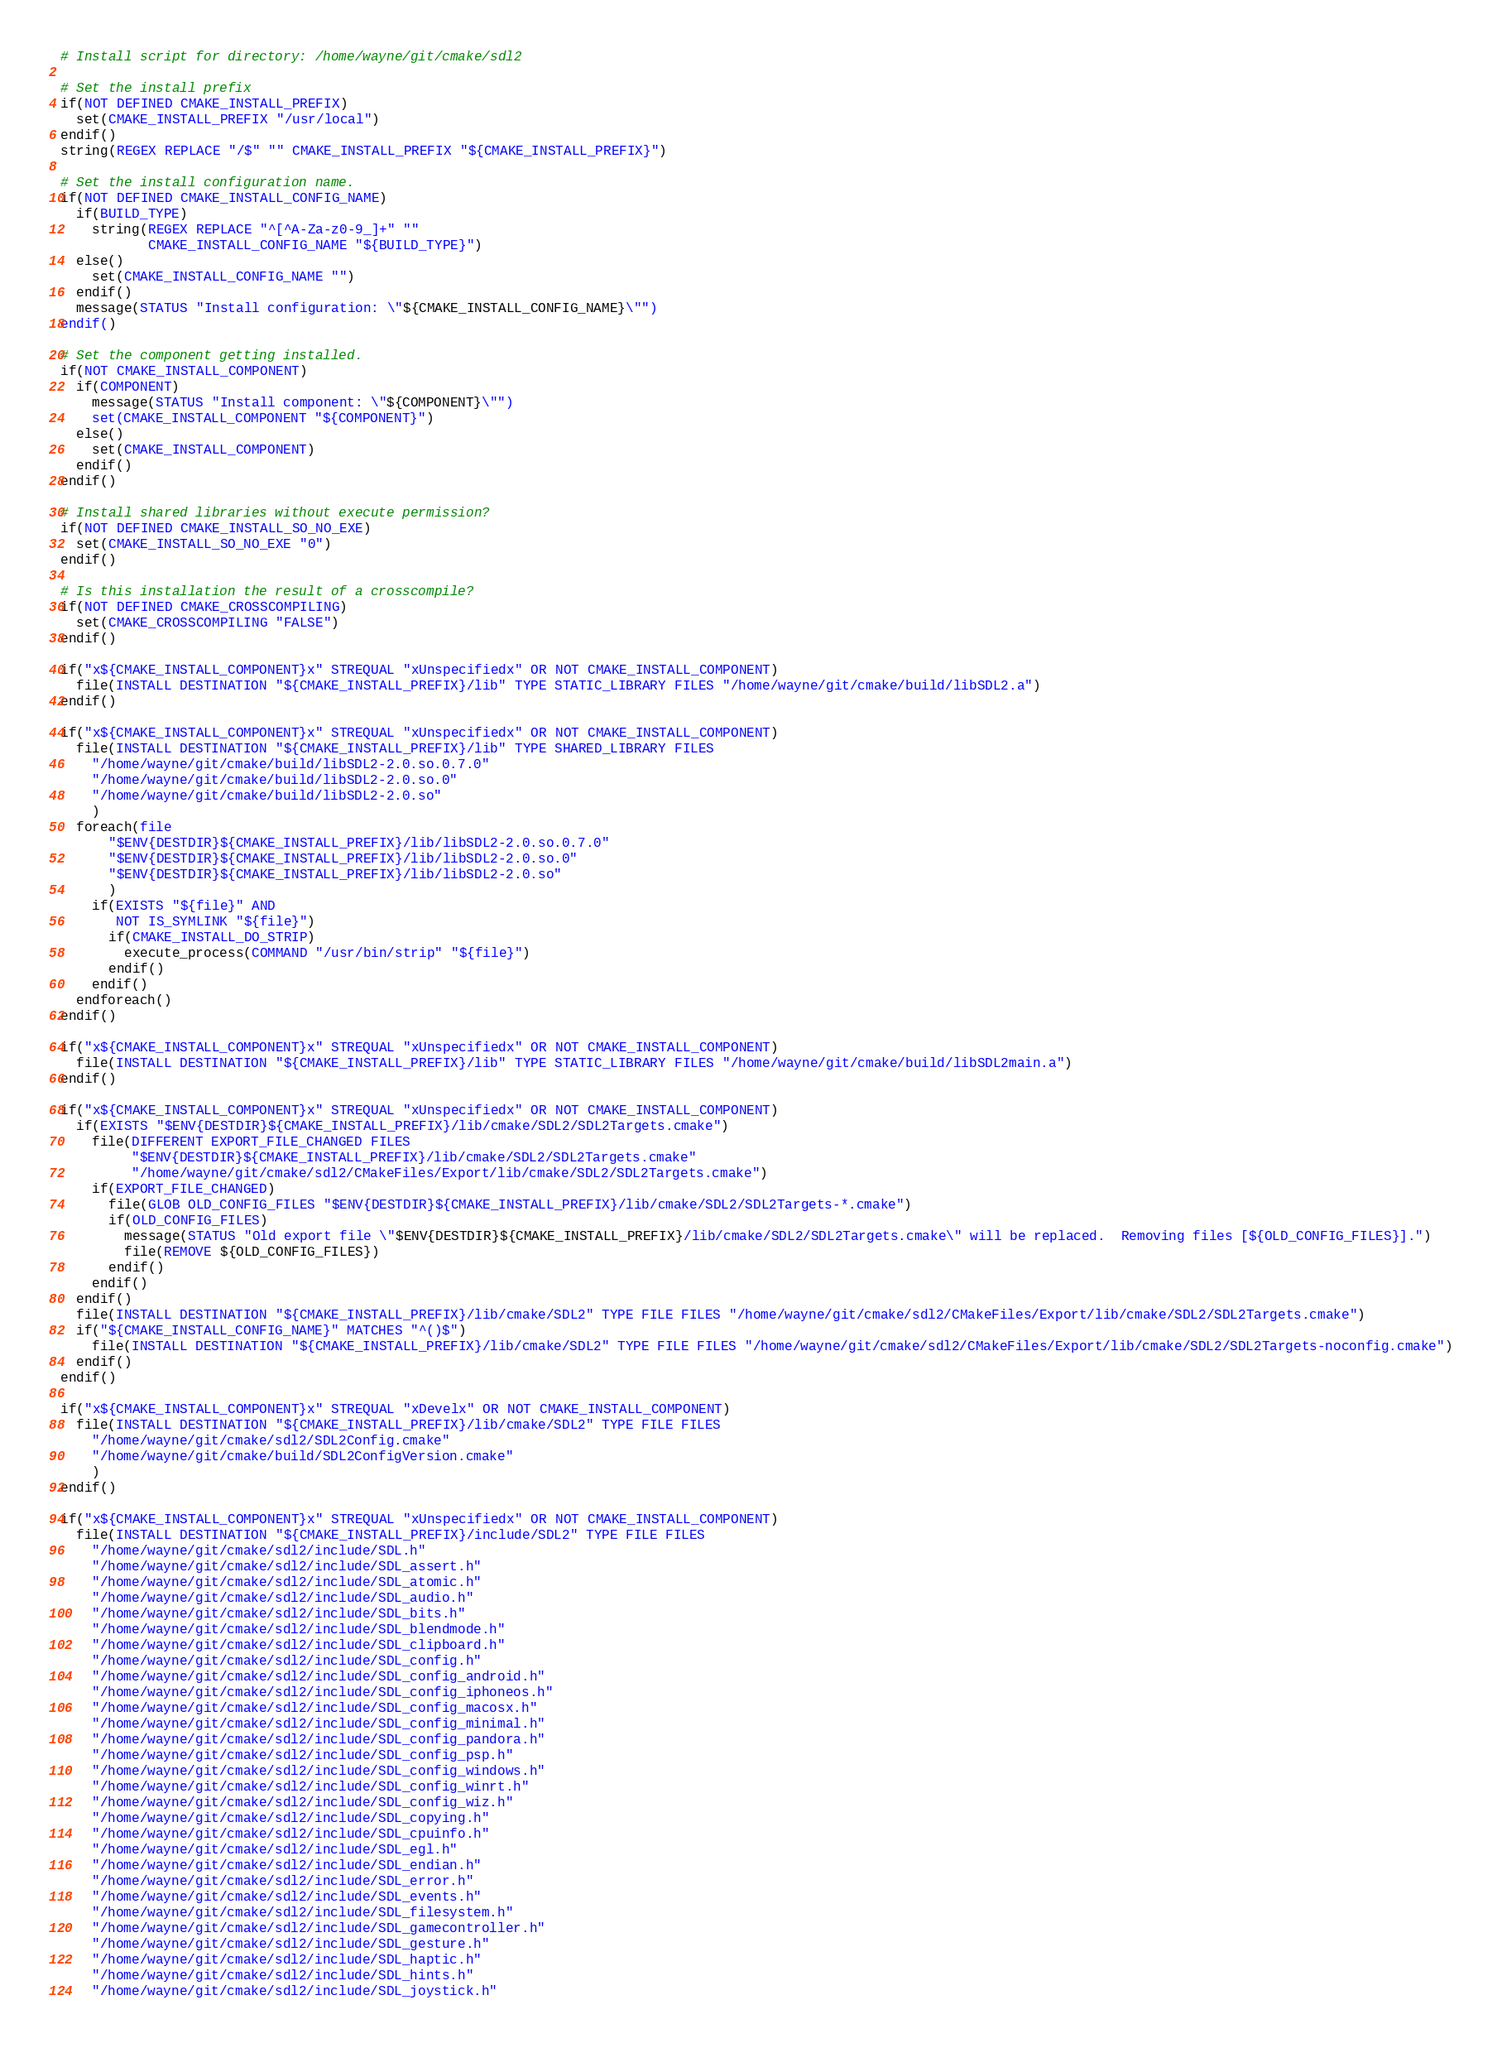Convert code to text. <code><loc_0><loc_0><loc_500><loc_500><_CMake_># Install script for directory: /home/wayne/git/cmake/sdl2

# Set the install prefix
if(NOT DEFINED CMAKE_INSTALL_PREFIX)
  set(CMAKE_INSTALL_PREFIX "/usr/local")
endif()
string(REGEX REPLACE "/$" "" CMAKE_INSTALL_PREFIX "${CMAKE_INSTALL_PREFIX}")

# Set the install configuration name.
if(NOT DEFINED CMAKE_INSTALL_CONFIG_NAME)
  if(BUILD_TYPE)
    string(REGEX REPLACE "^[^A-Za-z0-9_]+" ""
           CMAKE_INSTALL_CONFIG_NAME "${BUILD_TYPE}")
  else()
    set(CMAKE_INSTALL_CONFIG_NAME "")
  endif()
  message(STATUS "Install configuration: \"${CMAKE_INSTALL_CONFIG_NAME}\"")
endif()

# Set the component getting installed.
if(NOT CMAKE_INSTALL_COMPONENT)
  if(COMPONENT)
    message(STATUS "Install component: \"${COMPONENT}\"")
    set(CMAKE_INSTALL_COMPONENT "${COMPONENT}")
  else()
    set(CMAKE_INSTALL_COMPONENT)
  endif()
endif()

# Install shared libraries without execute permission?
if(NOT DEFINED CMAKE_INSTALL_SO_NO_EXE)
  set(CMAKE_INSTALL_SO_NO_EXE "0")
endif()

# Is this installation the result of a crosscompile?
if(NOT DEFINED CMAKE_CROSSCOMPILING)
  set(CMAKE_CROSSCOMPILING "FALSE")
endif()

if("x${CMAKE_INSTALL_COMPONENT}x" STREQUAL "xUnspecifiedx" OR NOT CMAKE_INSTALL_COMPONENT)
  file(INSTALL DESTINATION "${CMAKE_INSTALL_PREFIX}/lib" TYPE STATIC_LIBRARY FILES "/home/wayne/git/cmake/build/libSDL2.a")
endif()

if("x${CMAKE_INSTALL_COMPONENT}x" STREQUAL "xUnspecifiedx" OR NOT CMAKE_INSTALL_COMPONENT)
  file(INSTALL DESTINATION "${CMAKE_INSTALL_PREFIX}/lib" TYPE SHARED_LIBRARY FILES
    "/home/wayne/git/cmake/build/libSDL2-2.0.so.0.7.0"
    "/home/wayne/git/cmake/build/libSDL2-2.0.so.0"
    "/home/wayne/git/cmake/build/libSDL2-2.0.so"
    )
  foreach(file
      "$ENV{DESTDIR}${CMAKE_INSTALL_PREFIX}/lib/libSDL2-2.0.so.0.7.0"
      "$ENV{DESTDIR}${CMAKE_INSTALL_PREFIX}/lib/libSDL2-2.0.so.0"
      "$ENV{DESTDIR}${CMAKE_INSTALL_PREFIX}/lib/libSDL2-2.0.so"
      )
    if(EXISTS "${file}" AND
       NOT IS_SYMLINK "${file}")
      if(CMAKE_INSTALL_DO_STRIP)
        execute_process(COMMAND "/usr/bin/strip" "${file}")
      endif()
    endif()
  endforeach()
endif()

if("x${CMAKE_INSTALL_COMPONENT}x" STREQUAL "xUnspecifiedx" OR NOT CMAKE_INSTALL_COMPONENT)
  file(INSTALL DESTINATION "${CMAKE_INSTALL_PREFIX}/lib" TYPE STATIC_LIBRARY FILES "/home/wayne/git/cmake/build/libSDL2main.a")
endif()

if("x${CMAKE_INSTALL_COMPONENT}x" STREQUAL "xUnspecifiedx" OR NOT CMAKE_INSTALL_COMPONENT)
  if(EXISTS "$ENV{DESTDIR}${CMAKE_INSTALL_PREFIX}/lib/cmake/SDL2/SDL2Targets.cmake")
    file(DIFFERENT EXPORT_FILE_CHANGED FILES
         "$ENV{DESTDIR}${CMAKE_INSTALL_PREFIX}/lib/cmake/SDL2/SDL2Targets.cmake"
         "/home/wayne/git/cmake/sdl2/CMakeFiles/Export/lib/cmake/SDL2/SDL2Targets.cmake")
    if(EXPORT_FILE_CHANGED)
      file(GLOB OLD_CONFIG_FILES "$ENV{DESTDIR}${CMAKE_INSTALL_PREFIX}/lib/cmake/SDL2/SDL2Targets-*.cmake")
      if(OLD_CONFIG_FILES)
        message(STATUS "Old export file \"$ENV{DESTDIR}${CMAKE_INSTALL_PREFIX}/lib/cmake/SDL2/SDL2Targets.cmake\" will be replaced.  Removing files [${OLD_CONFIG_FILES}].")
        file(REMOVE ${OLD_CONFIG_FILES})
      endif()
    endif()
  endif()
  file(INSTALL DESTINATION "${CMAKE_INSTALL_PREFIX}/lib/cmake/SDL2" TYPE FILE FILES "/home/wayne/git/cmake/sdl2/CMakeFiles/Export/lib/cmake/SDL2/SDL2Targets.cmake")
  if("${CMAKE_INSTALL_CONFIG_NAME}" MATCHES "^()$")
    file(INSTALL DESTINATION "${CMAKE_INSTALL_PREFIX}/lib/cmake/SDL2" TYPE FILE FILES "/home/wayne/git/cmake/sdl2/CMakeFiles/Export/lib/cmake/SDL2/SDL2Targets-noconfig.cmake")
  endif()
endif()

if("x${CMAKE_INSTALL_COMPONENT}x" STREQUAL "xDevelx" OR NOT CMAKE_INSTALL_COMPONENT)
  file(INSTALL DESTINATION "${CMAKE_INSTALL_PREFIX}/lib/cmake/SDL2" TYPE FILE FILES
    "/home/wayne/git/cmake/sdl2/SDL2Config.cmake"
    "/home/wayne/git/cmake/build/SDL2ConfigVersion.cmake"
    )
endif()

if("x${CMAKE_INSTALL_COMPONENT}x" STREQUAL "xUnspecifiedx" OR NOT CMAKE_INSTALL_COMPONENT)
  file(INSTALL DESTINATION "${CMAKE_INSTALL_PREFIX}/include/SDL2" TYPE FILE FILES
    "/home/wayne/git/cmake/sdl2/include/SDL.h"
    "/home/wayne/git/cmake/sdl2/include/SDL_assert.h"
    "/home/wayne/git/cmake/sdl2/include/SDL_atomic.h"
    "/home/wayne/git/cmake/sdl2/include/SDL_audio.h"
    "/home/wayne/git/cmake/sdl2/include/SDL_bits.h"
    "/home/wayne/git/cmake/sdl2/include/SDL_blendmode.h"
    "/home/wayne/git/cmake/sdl2/include/SDL_clipboard.h"
    "/home/wayne/git/cmake/sdl2/include/SDL_config.h"
    "/home/wayne/git/cmake/sdl2/include/SDL_config_android.h"
    "/home/wayne/git/cmake/sdl2/include/SDL_config_iphoneos.h"
    "/home/wayne/git/cmake/sdl2/include/SDL_config_macosx.h"
    "/home/wayne/git/cmake/sdl2/include/SDL_config_minimal.h"
    "/home/wayne/git/cmake/sdl2/include/SDL_config_pandora.h"
    "/home/wayne/git/cmake/sdl2/include/SDL_config_psp.h"
    "/home/wayne/git/cmake/sdl2/include/SDL_config_windows.h"
    "/home/wayne/git/cmake/sdl2/include/SDL_config_winrt.h"
    "/home/wayne/git/cmake/sdl2/include/SDL_config_wiz.h"
    "/home/wayne/git/cmake/sdl2/include/SDL_copying.h"
    "/home/wayne/git/cmake/sdl2/include/SDL_cpuinfo.h"
    "/home/wayne/git/cmake/sdl2/include/SDL_egl.h"
    "/home/wayne/git/cmake/sdl2/include/SDL_endian.h"
    "/home/wayne/git/cmake/sdl2/include/SDL_error.h"
    "/home/wayne/git/cmake/sdl2/include/SDL_events.h"
    "/home/wayne/git/cmake/sdl2/include/SDL_filesystem.h"
    "/home/wayne/git/cmake/sdl2/include/SDL_gamecontroller.h"
    "/home/wayne/git/cmake/sdl2/include/SDL_gesture.h"
    "/home/wayne/git/cmake/sdl2/include/SDL_haptic.h"
    "/home/wayne/git/cmake/sdl2/include/SDL_hints.h"
    "/home/wayne/git/cmake/sdl2/include/SDL_joystick.h"</code> 